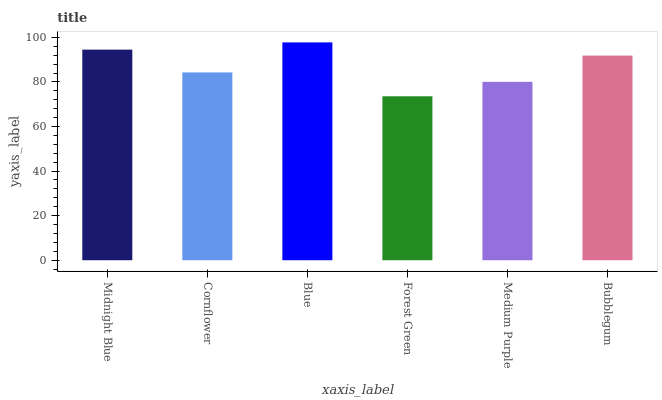Is Forest Green the minimum?
Answer yes or no. Yes. Is Blue the maximum?
Answer yes or no. Yes. Is Cornflower the minimum?
Answer yes or no. No. Is Cornflower the maximum?
Answer yes or no. No. Is Midnight Blue greater than Cornflower?
Answer yes or no. Yes. Is Cornflower less than Midnight Blue?
Answer yes or no. Yes. Is Cornflower greater than Midnight Blue?
Answer yes or no. No. Is Midnight Blue less than Cornflower?
Answer yes or no. No. Is Bubblegum the high median?
Answer yes or no. Yes. Is Cornflower the low median?
Answer yes or no. Yes. Is Blue the high median?
Answer yes or no. No. Is Forest Green the low median?
Answer yes or no. No. 